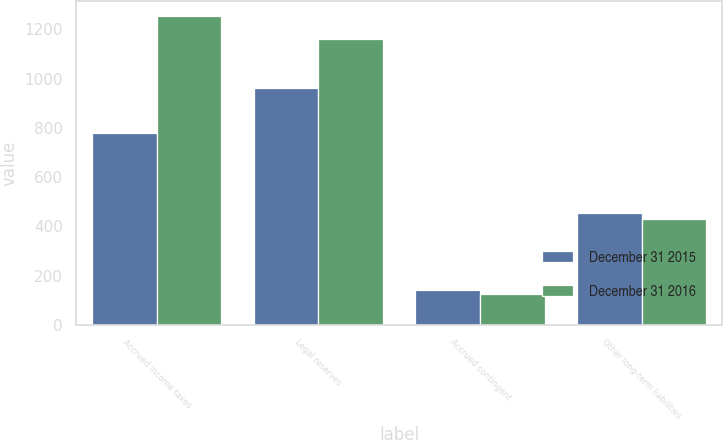<chart> <loc_0><loc_0><loc_500><loc_500><stacked_bar_chart><ecel><fcel>Accrued income taxes<fcel>Legal reserves<fcel>Accrued contingent<fcel>Other long-term liabilities<nl><fcel>December 31 2015<fcel>781<fcel>961<fcel>141<fcel>455<nl><fcel>December 31 2016<fcel>1253<fcel>1163<fcel>127<fcel>431<nl></chart> 